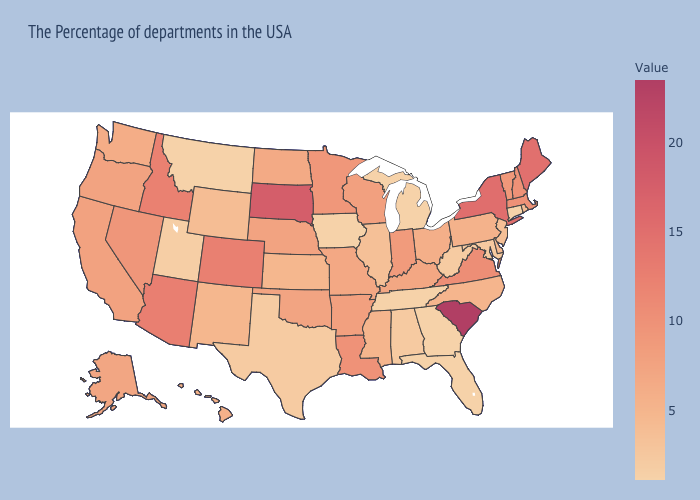Does Missouri have the lowest value in the MidWest?
Quick response, please. No. Does Mississippi have the highest value in the South?
Be succinct. No. Which states have the lowest value in the West?
Write a very short answer. Montana. Is the legend a continuous bar?
Short answer required. Yes. Does South Carolina have the highest value in the USA?
Keep it brief. Yes. Does North Carolina have the lowest value in the USA?
Give a very brief answer. No. 